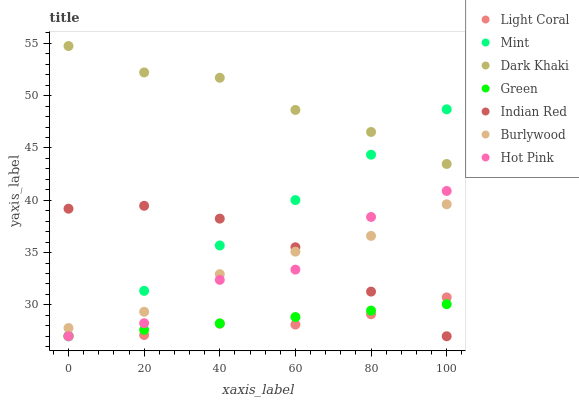Does Light Coral have the minimum area under the curve?
Answer yes or no. Yes. Does Dark Khaki have the maximum area under the curve?
Answer yes or no. Yes. Does Burlywood have the minimum area under the curve?
Answer yes or no. No. Does Burlywood have the maximum area under the curve?
Answer yes or no. No. Is Green the smoothest?
Answer yes or no. Yes. Is Hot Pink the roughest?
Answer yes or no. Yes. Is Burlywood the smoothest?
Answer yes or no. No. Is Burlywood the roughest?
Answer yes or no. No. Does Hot Pink have the lowest value?
Answer yes or no. Yes. Does Burlywood have the lowest value?
Answer yes or no. No. Does Dark Khaki have the highest value?
Answer yes or no. Yes. Does Burlywood have the highest value?
Answer yes or no. No. Is Indian Red less than Dark Khaki?
Answer yes or no. Yes. Is Burlywood greater than Green?
Answer yes or no. Yes. Does Burlywood intersect Mint?
Answer yes or no. Yes. Is Burlywood less than Mint?
Answer yes or no. No. Is Burlywood greater than Mint?
Answer yes or no. No. Does Indian Red intersect Dark Khaki?
Answer yes or no. No. 